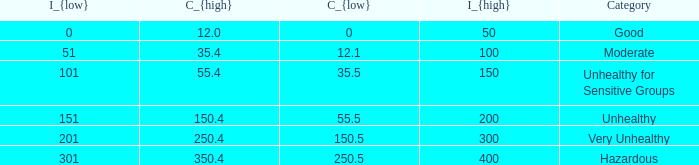What's the C_{high} when the C_{low} value is 250.5? 350.4. Would you be able to parse every entry in this table? {'header': ['I_{low}', 'C_{high}', 'C_{low}', 'I_{high}', 'Category'], 'rows': [['0', '12.0', '0', '50', 'Good'], ['51', '35.4', '12.1', '100', 'Moderate'], ['101', '55.4', '35.5', '150', 'Unhealthy for Sensitive Groups'], ['151', '150.4', '55.5', '200', 'Unhealthy'], ['201', '250.4', '150.5', '300', 'Very Unhealthy'], ['301', '350.4', '250.5', '400', 'Hazardous']]} 